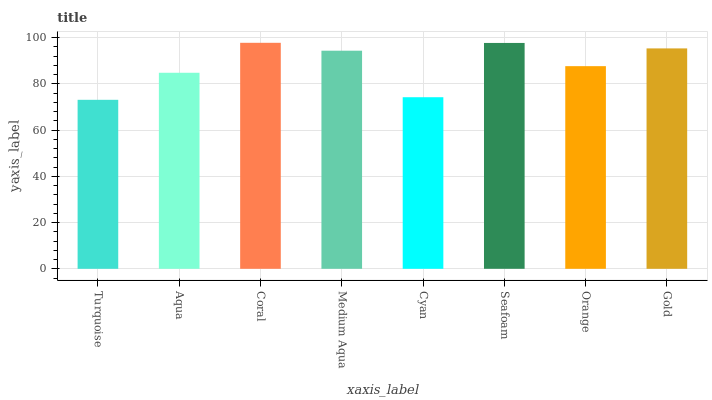Is Aqua the minimum?
Answer yes or no. No. Is Aqua the maximum?
Answer yes or no. No. Is Aqua greater than Turquoise?
Answer yes or no. Yes. Is Turquoise less than Aqua?
Answer yes or no. Yes. Is Turquoise greater than Aqua?
Answer yes or no. No. Is Aqua less than Turquoise?
Answer yes or no. No. Is Medium Aqua the high median?
Answer yes or no. Yes. Is Orange the low median?
Answer yes or no. Yes. Is Orange the high median?
Answer yes or no. No. Is Medium Aqua the low median?
Answer yes or no. No. 